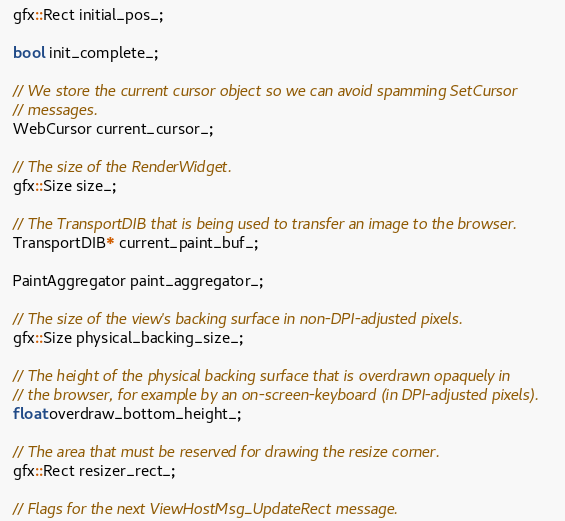<code> <loc_0><loc_0><loc_500><loc_500><_C_>  gfx::Rect initial_pos_;

  bool init_complete_;

  // We store the current cursor object so we can avoid spamming SetCursor
  // messages.
  WebCursor current_cursor_;

  // The size of the RenderWidget.
  gfx::Size size_;

  // The TransportDIB that is being used to transfer an image to the browser.
  TransportDIB* current_paint_buf_;

  PaintAggregator paint_aggregator_;

  // The size of the view's backing surface in non-DPI-adjusted pixels.
  gfx::Size physical_backing_size_;

  // The height of the physical backing surface that is overdrawn opaquely in
  // the browser, for example by an on-screen-keyboard (in DPI-adjusted pixels).
  float overdraw_bottom_height_;

  // The area that must be reserved for drawing the resize corner.
  gfx::Rect resizer_rect_;

  // Flags for the next ViewHostMsg_UpdateRect message.</code> 